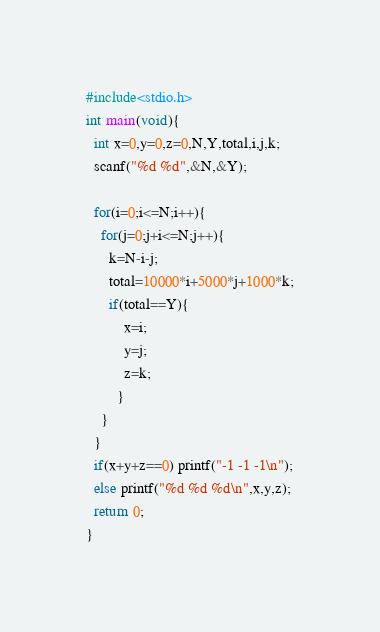<code> <loc_0><loc_0><loc_500><loc_500><_C_>
#include<stdio.h>
int main(void){
  int x=0,y=0,z=0,N,Y,total,i,j,k;
  scanf("%d %d",&N,&Y);

  for(i=0;i<=N;i++){
    for(j=0;j+i<=N;j++){
      k=N-i-j;
      total=10000*i+5000*j+1000*k;
      if(total==Y){
          x=i;
          y=j;
          z=k;
        }
    }
  }
  if(x+y+z==0) printf("-1 -1 -1\n");
  else printf("%d %d %d\n",x,y,z);
  return 0;
}
</code> 